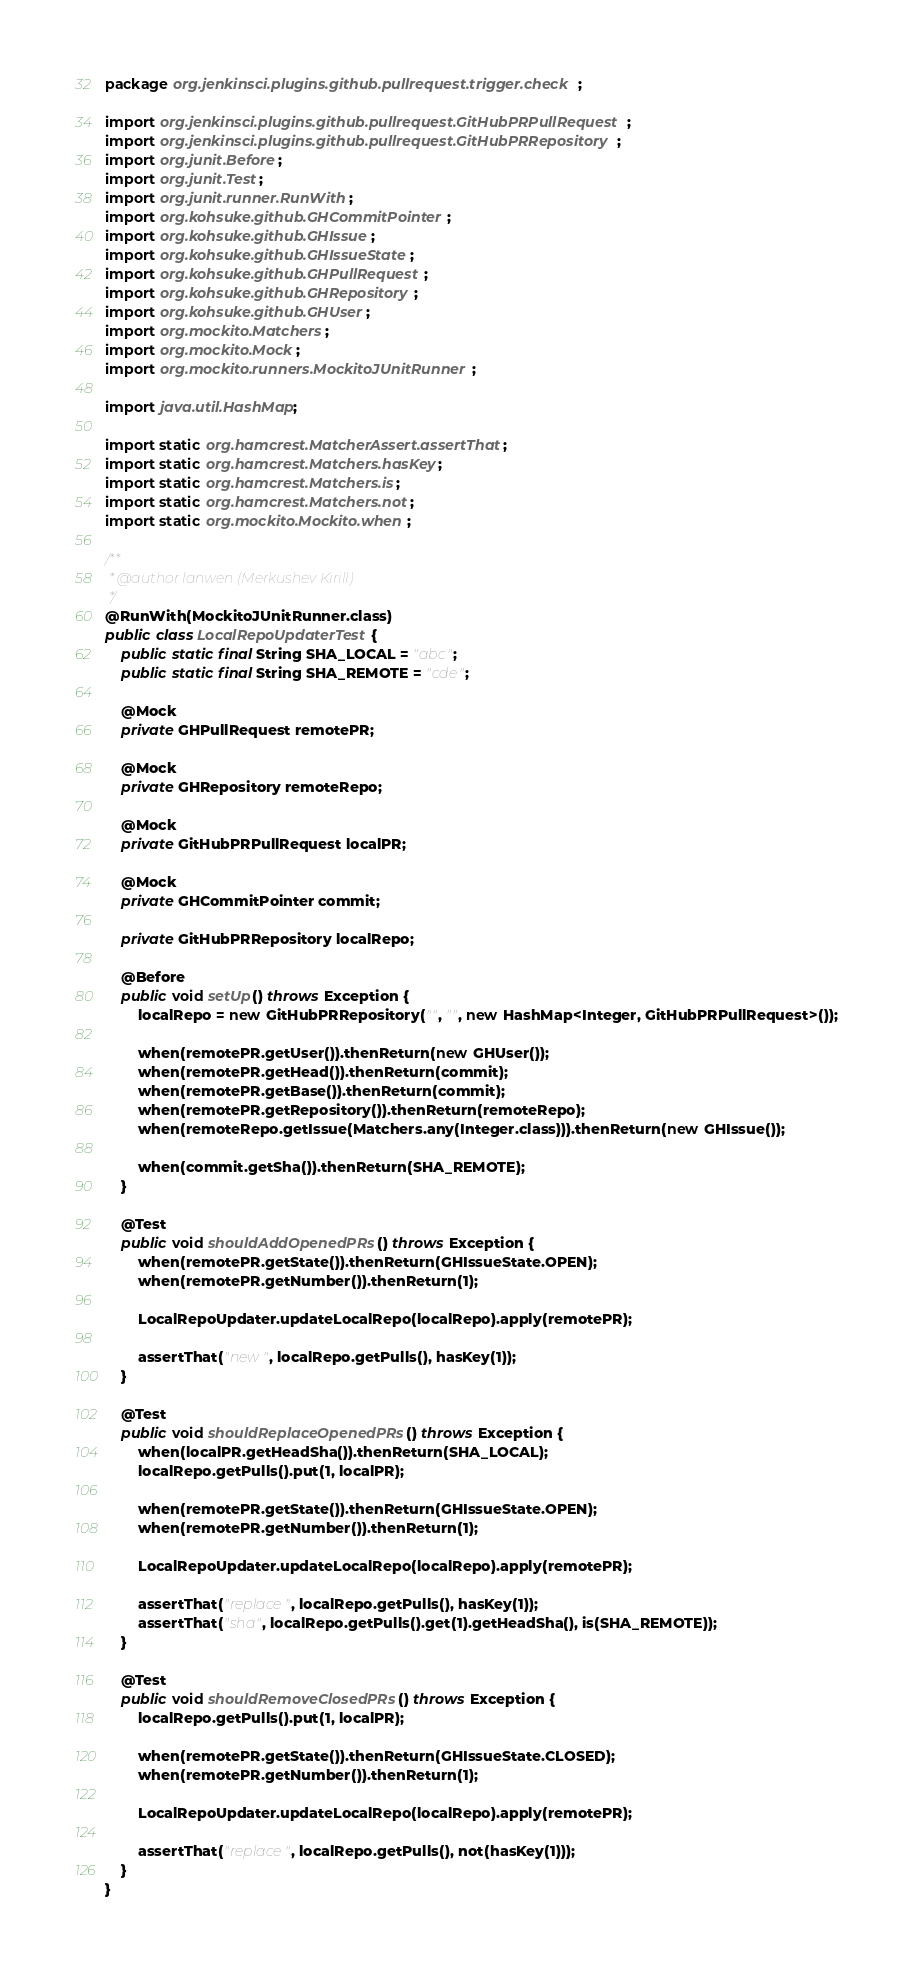Convert code to text. <code><loc_0><loc_0><loc_500><loc_500><_Java_>package org.jenkinsci.plugins.github.pullrequest.trigger.check;

import org.jenkinsci.plugins.github.pullrequest.GitHubPRPullRequest;
import org.jenkinsci.plugins.github.pullrequest.GitHubPRRepository;
import org.junit.Before;
import org.junit.Test;
import org.junit.runner.RunWith;
import org.kohsuke.github.GHCommitPointer;
import org.kohsuke.github.GHIssue;
import org.kohsuke.github.GHIssueState;
import org.kohsuke.github.GHPullRequest;
import org.kohsuke.github.GHRepository;
import org.kohsuke.github.GHUser;
import org.mockito.Matchers;
import org.mockito.Mock;
import org.mockito.runners.MockitoJUnitRunner;

import java.util.HashMap;

import static org.hamcrest.MatcherAssert.assertThat;
import static org.hamcrest.Matchers.hasKey;
import static org.hamcrest.Matchers.is;
import static org.hamcrest.Matchers.not;
import static org.mockito.Mockito.when;

/**
 * @author lanwen (Merkushev Kirill)
 */
@RunWith(MockitoJUnitRunner.class)
public class LocalRepoUpdaterTest {
    public static final String SHA_LOCAL = "abc";
    public static final String SHA_REMOTE = "cde";

    @Mock
    private GHPullRequest remotePR;

    @Mock
    private GHRepository remoteRepo;

    @Mock
    private GitHubPRPullRequest localPR;

    @Mock
    private GHCommitPointer commit;

    private GitHubPRRepository localRepo;

    @Before
    public void setUp() throws Exception {
        localRepo = new GitHubPRRepository("", "", new HashMap<Integer, GitHubPRPullRequest>());

        when(remotePR.getUser()).thenReturn(new GHUser());
        when(remotePR.getHead()).thenReturn(commit);
        when(remotePR.getBase()).thenReturn(commit);
        when(remotePR.getRepository()).thenReturn(remoteRepo);
        when(remoteRepo.getIssue(Matchers.any(Integer.class))).thenReturn(new GHIssue());

        when(commit.getSha()).thenReturn(SHA_REMOTE);
    }

    @Test
    public void shouldAddOpenedPRs() throws Exception {
        when(remotePR.getState()).thenReturn(GHIssueState.OPEN);
        when(remotePR.getNumber()).thenReturn(1);

        LocalRepoUpdater.updateLocalRepo(localRepo).apply(remotePR);

        assertThat("new", localRepo.getPulls(), hasKey(1));
    }

    @Test
    public void shouldReplaceOpenedPRs() throws Exception {
        when(localPR.getHeadSha()).thenReturn(SHA_LOCAL);
        localRepo.getPulls().put(1, localPR);

        when(remotePR.getState()).thenReturn(GHIssueState.OPEN);
        when(remotePR.getNumber()).thenReturn(1);

        LocalRepoUpdater.updateLocalRepo(localRepo).apply(remotePR);

        assertThat("replace", localRepo.getPulls(), hasKey(1));
        assertThat("sha", localRepo.getPulls().get(1).getHeadSha(), is(SHA_REMOTE));
    }

    @Test
    public void shouldRemoveClosedPRs() throws Exception {
        localRepo.getPulls().put(1, localPR);

        when(remotePR.getState()).thenReturn(GHIssueState.CLOSED);
        when(remotePR.getNumber()).thenReturn(1);

        LocalRepoUpdater.updateLocalRepo(localRepo).apply(remotePR);

        assertThat("replace", localRepo.getPulls(), not(hasKey(1)));
    }
}
</code> 